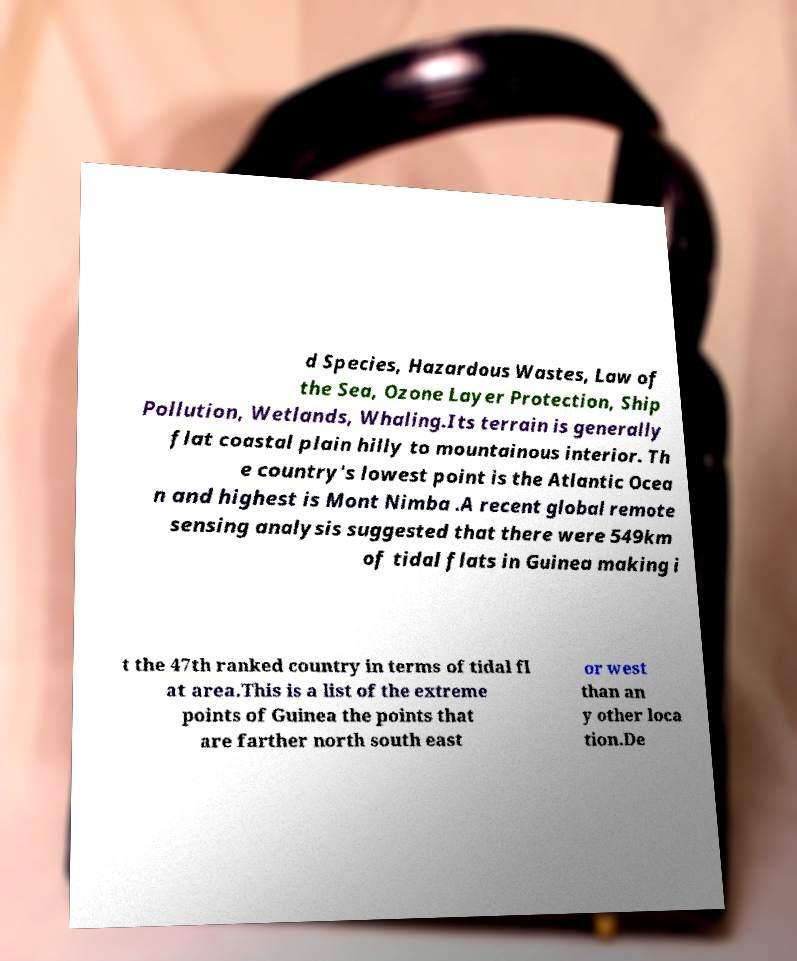For documentation purposes, I need the text within this image transcribed. Could you provide that? d Species, Hazardous Wastes, Law of the Sea, Ozone Layer Protection, Ship Pollution, Wetlands, Whaling.Its terrain is generally flat coastal plain hilly to mountainous interior. Th e country's lowest point is the Atlantic Ocea n and highest is Mont Nimba .A recent global remote sensing analysis suggested that there were 549km of tidal flats in Guinea making i t the 47th ranked country in terms of tidal fl at area.This is a list of the extreme points of Guinea the points that are farther north south east or west than an y other loca tion.De 